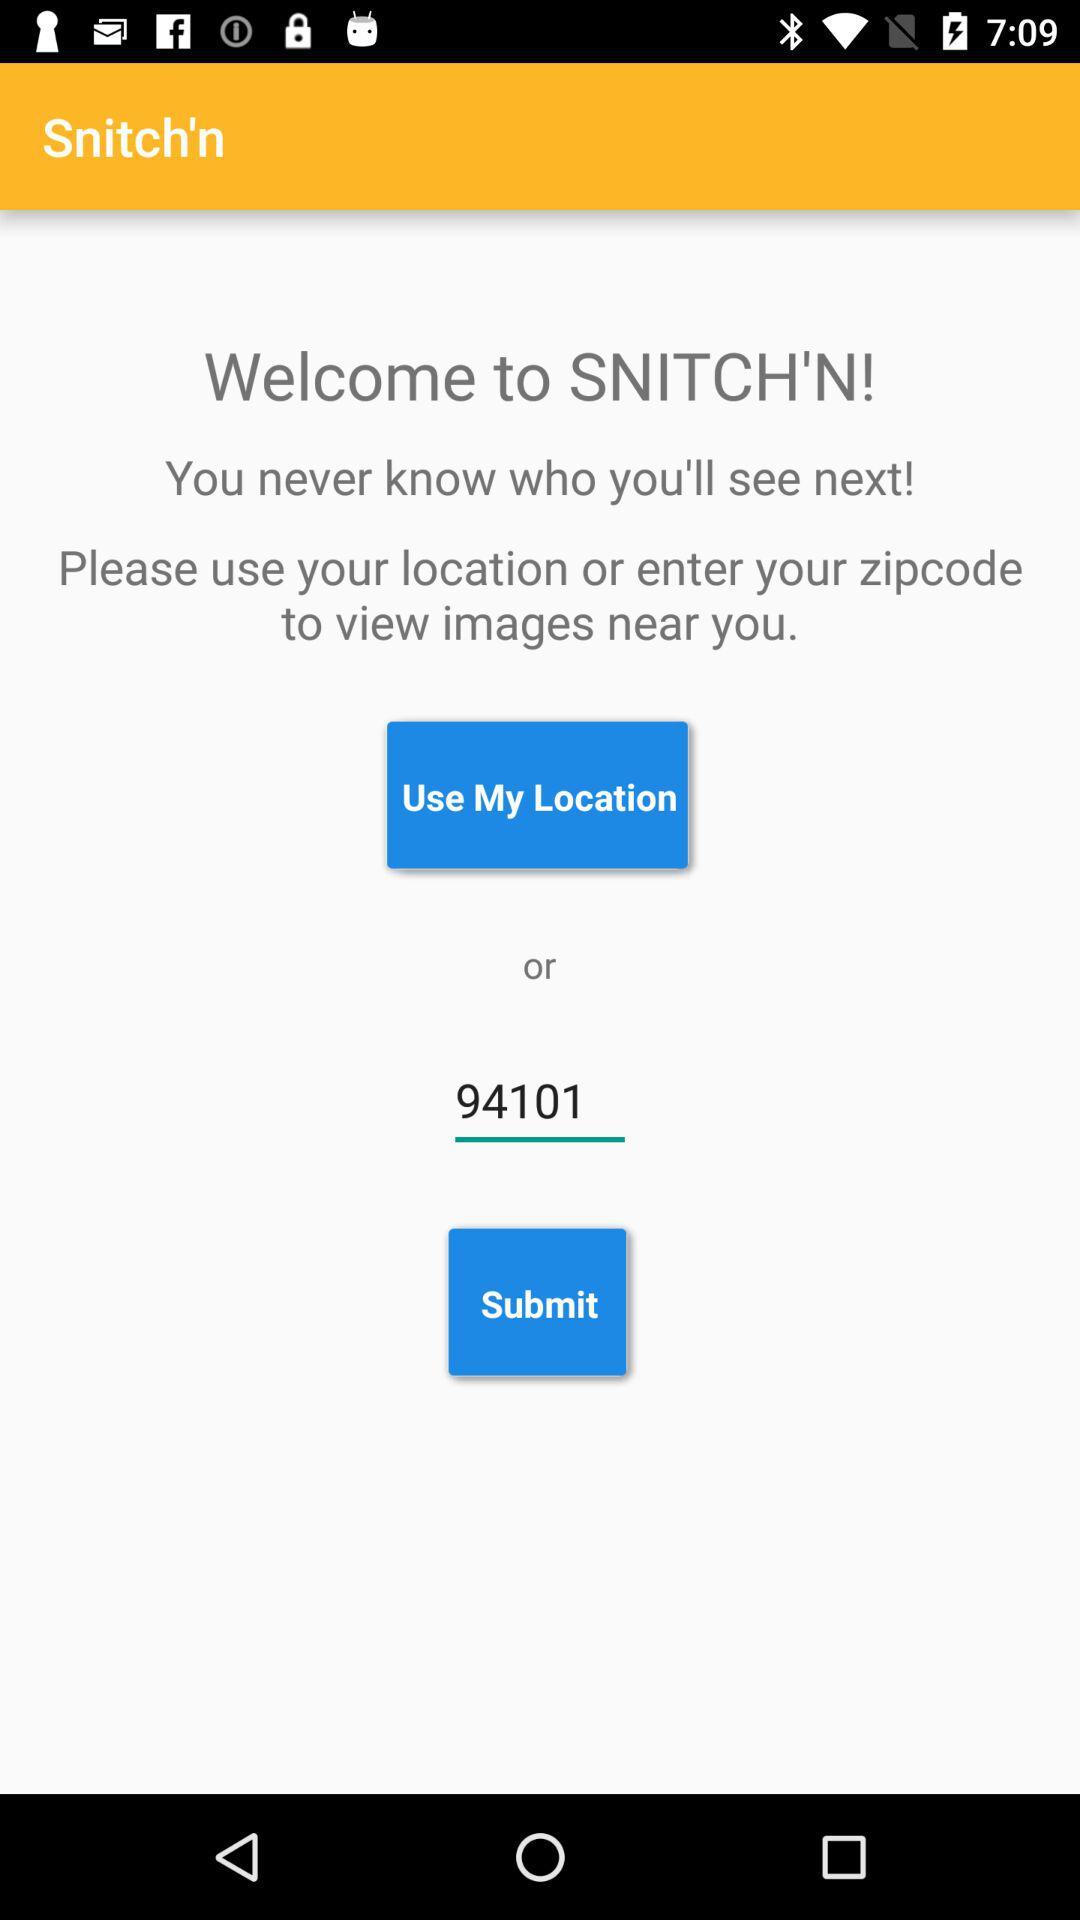What is the Zip code? The Zip code is 94101. 